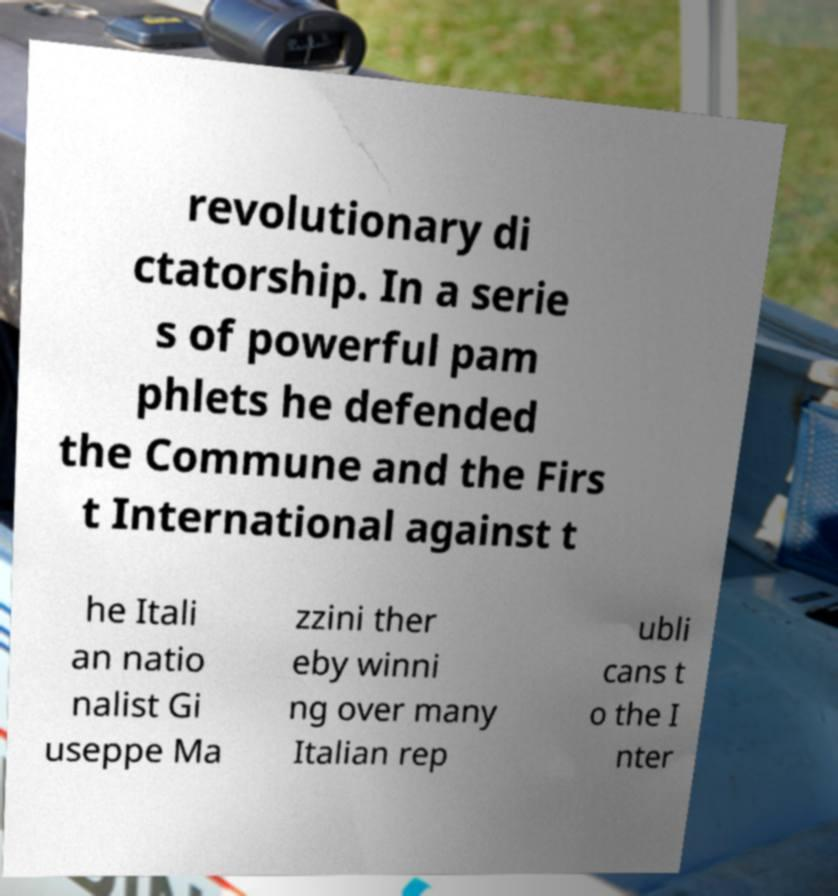Could you extract and type out the text from this image? revolutionary di ctatorship. In a serie s of powerful pam phlets he defended the Commune and the Firs t International against t he Itali an natio nalist Gi useppe Ma zzini ther eby winni ng over many Italian rep ubli cans t o the I nter 